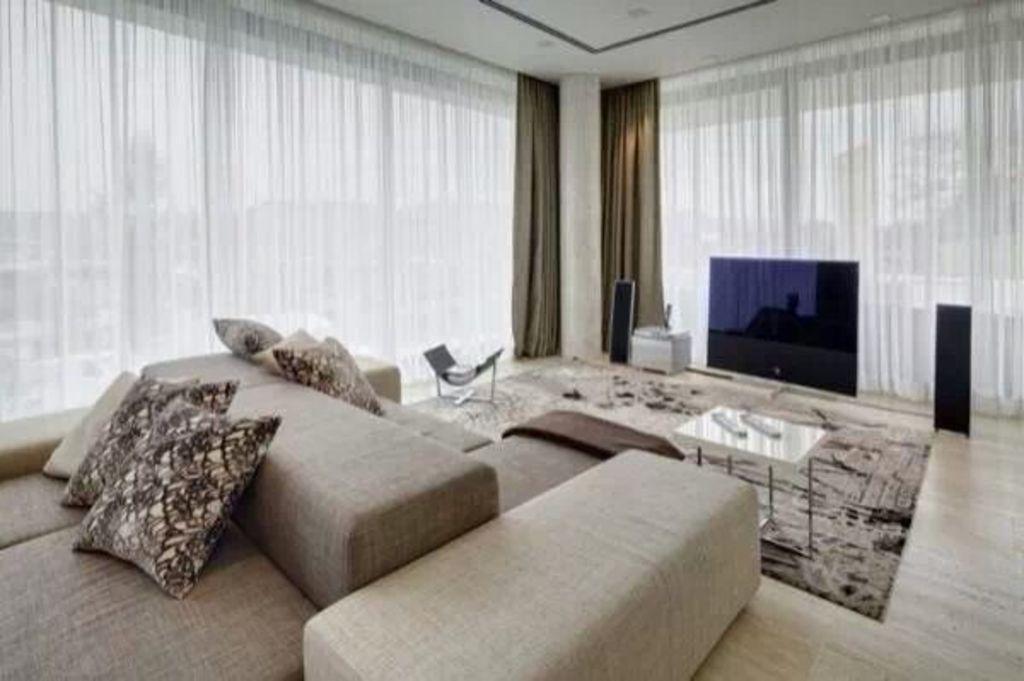Can you describe this image briefly? In this image there is one couch on the left side and on that couch there are some pillows and and in the middle of the image there is one television beside that television there are sound systems and on the floor there is one carpet and in front of the couch there is one table and on the top of the image there is window and curtains are there. 